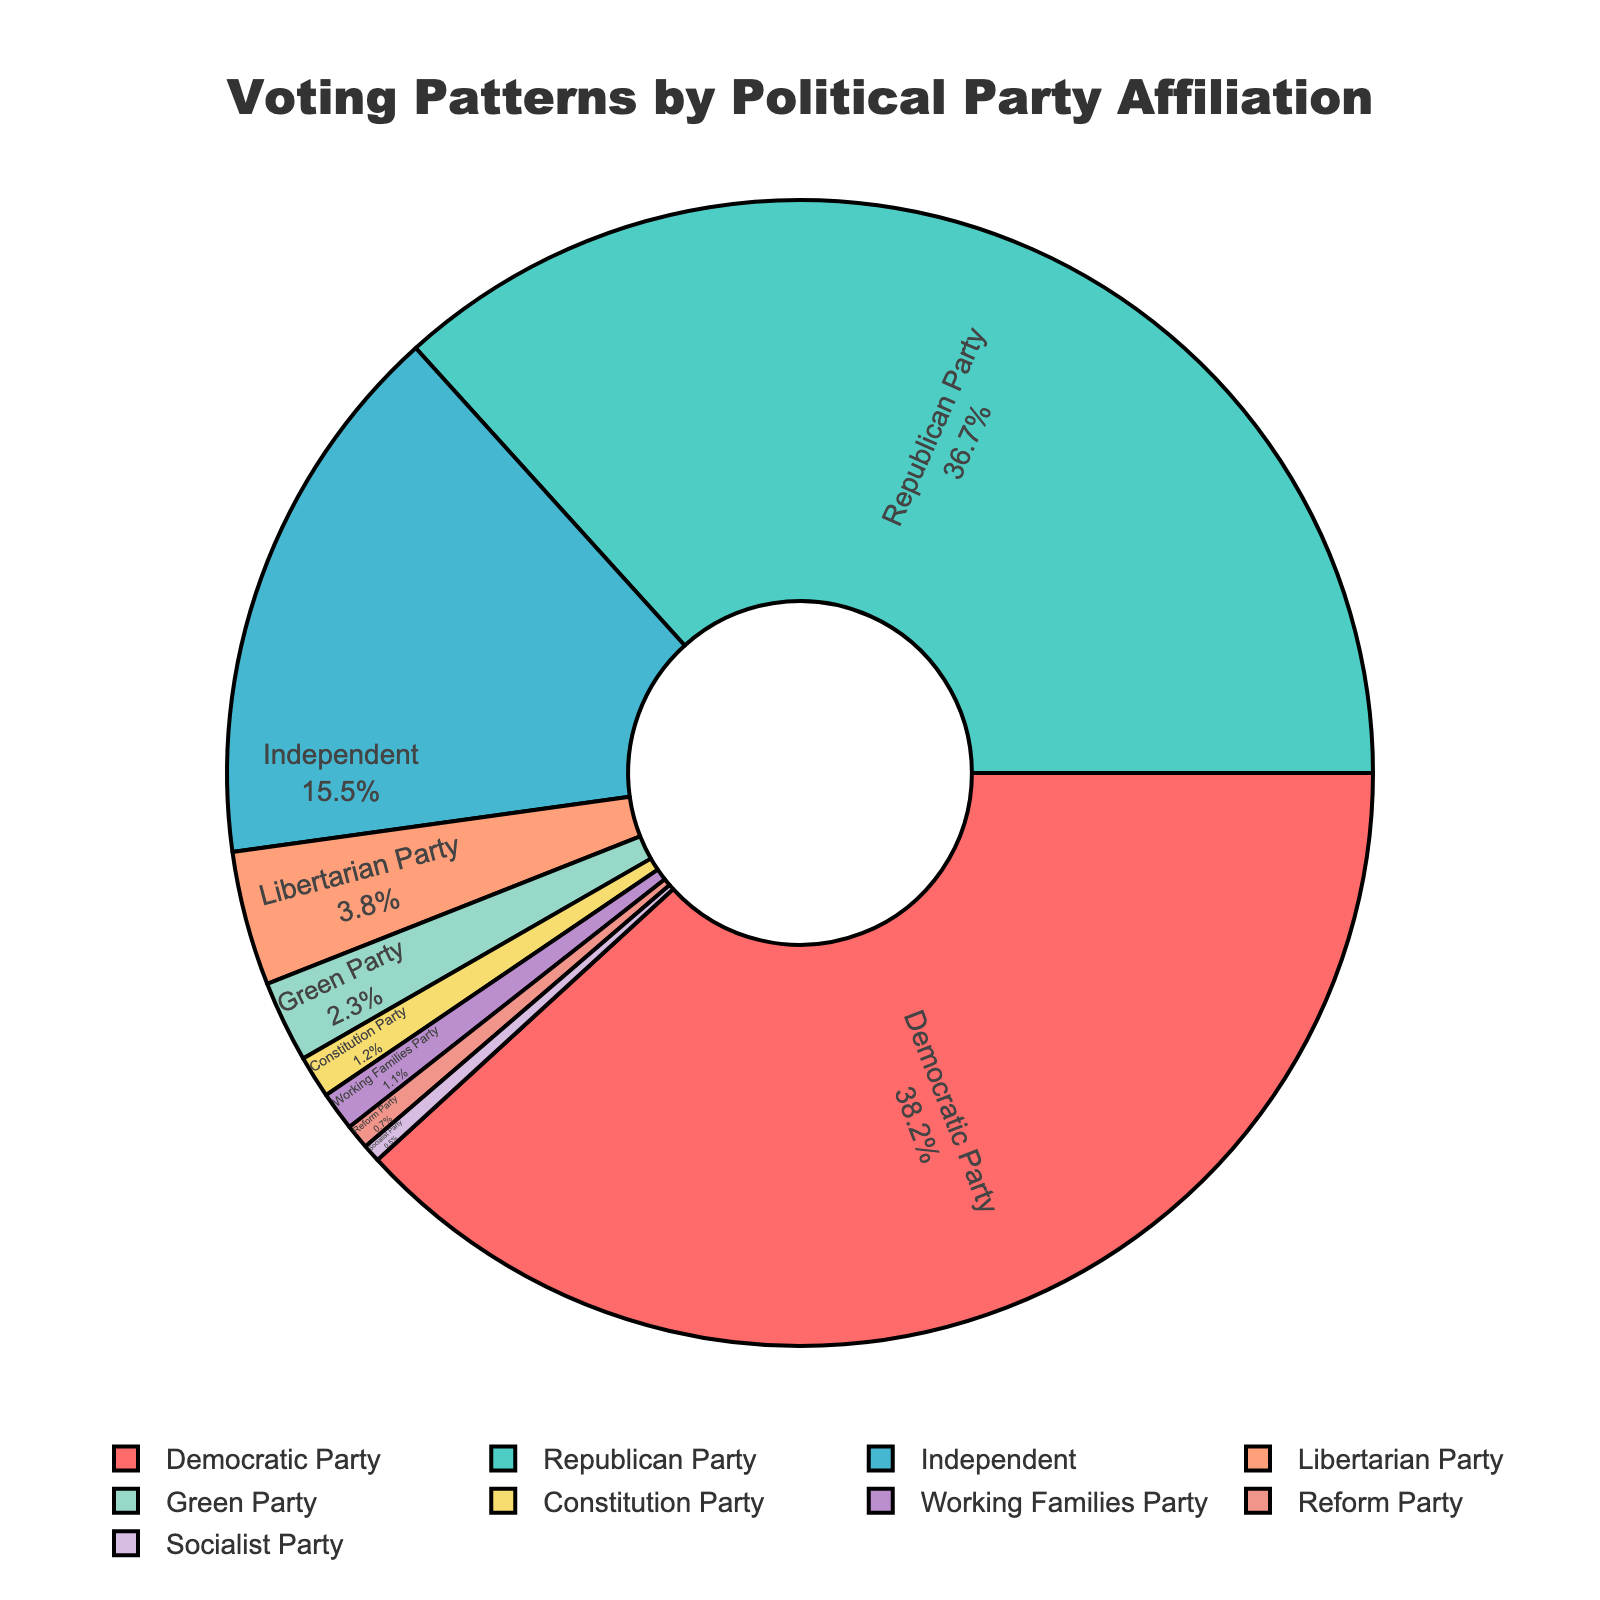What's the largest percentage of votes for a single party? Look at the pie chart and find the slice representing the highest percentage. In this case, the Democratic Party has the largest slice.
Answer: 38.2% Which two parties combined have more votes than the Democratic Party? The Democratic Party has 38.2%. Adding percentages until you exceed that number: the Republican Party (36.7%) and the Independent Party (15.5%). Their combined total is 52.2%, which is more.
Answer: Republican and Independent How much more percentage of votes did the Democratic Party get compared to the Libertarian Party? The Democratic Party's percentage is 38.2% and the Libertarian Party's is 3.8%. Subtracting these gives: 38.2 - 3.8.
Answer: 34.4% Which party has the smallest percentage of votes and what is it? Look for the smallest slice in the pie chart. The Socialist Party has the smallest, with 0.5%.
Answer: Socialist Party, 0.5% Compare the vote percentages of the Green Party and the Constitution Party. Which one received more votes? The Green Party has 2.3%, while the Constitution Party has 1.2%. Comparing these values shows that the Green Party received more votes.
Answer: Green Party What percentage of the vote did the parties with less than 5% votes get combined? Sum the percentages of the Libertarian Party (3.8%), Green Party (2.3%), Constitution Party (1.2%), Working Families Party (1.1%), Reform Party (0.7%), and Socialist Party (0.5%).
Answer: 9.6% What is the visual indication of the Republican Party's percentage? Look at the pie chart for visual attributes like color and size. The Republican Party slice, which is the second largest, will be a different color than adjacent slices and proportionately large.
Answer: Second largest slice, different color What is the difference in percentages between the top two parties? The Democratic Party has 38.2% of the vote and the Republican Party has 36.7%. Subtract the Republican Party's percentage from the Democratic Party's.
Answer: 1.5% Which non-major (neither Democratic nor Republican) party received the highest percentage of votes? Look at slices excluding the Democratic and Republican Parties. The Independent Party slice will be the next largest, having 15.5% of the vote.
Answer: Independent Party What is the average percentage of votes received by parties under 1%? Sum the percentages of parties under 1%: Constitution Party (1.2%), Working Families Party (1.1%), Reform Party (0.7%), Socialist Party (0.5%), and then divide by their count (5).
Answer: 0.88% 